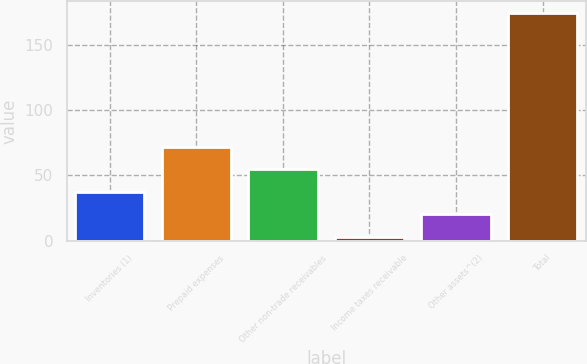Convert chart. <chart><loc_0><loc_0><loc_500><loc_500><bar_chart><fcel>Inventories (1)<fcel>Prepaid expenses<fcel>Other non-trade receivables<fcel>Income taxes receivable<fcel>Other assets^(2)<fcel>Total<nl><fcel>37.34<fcel>71.68<fcel>54.51<fcel>3<fcel>20.17<fcel>174.7<nl></chart> 